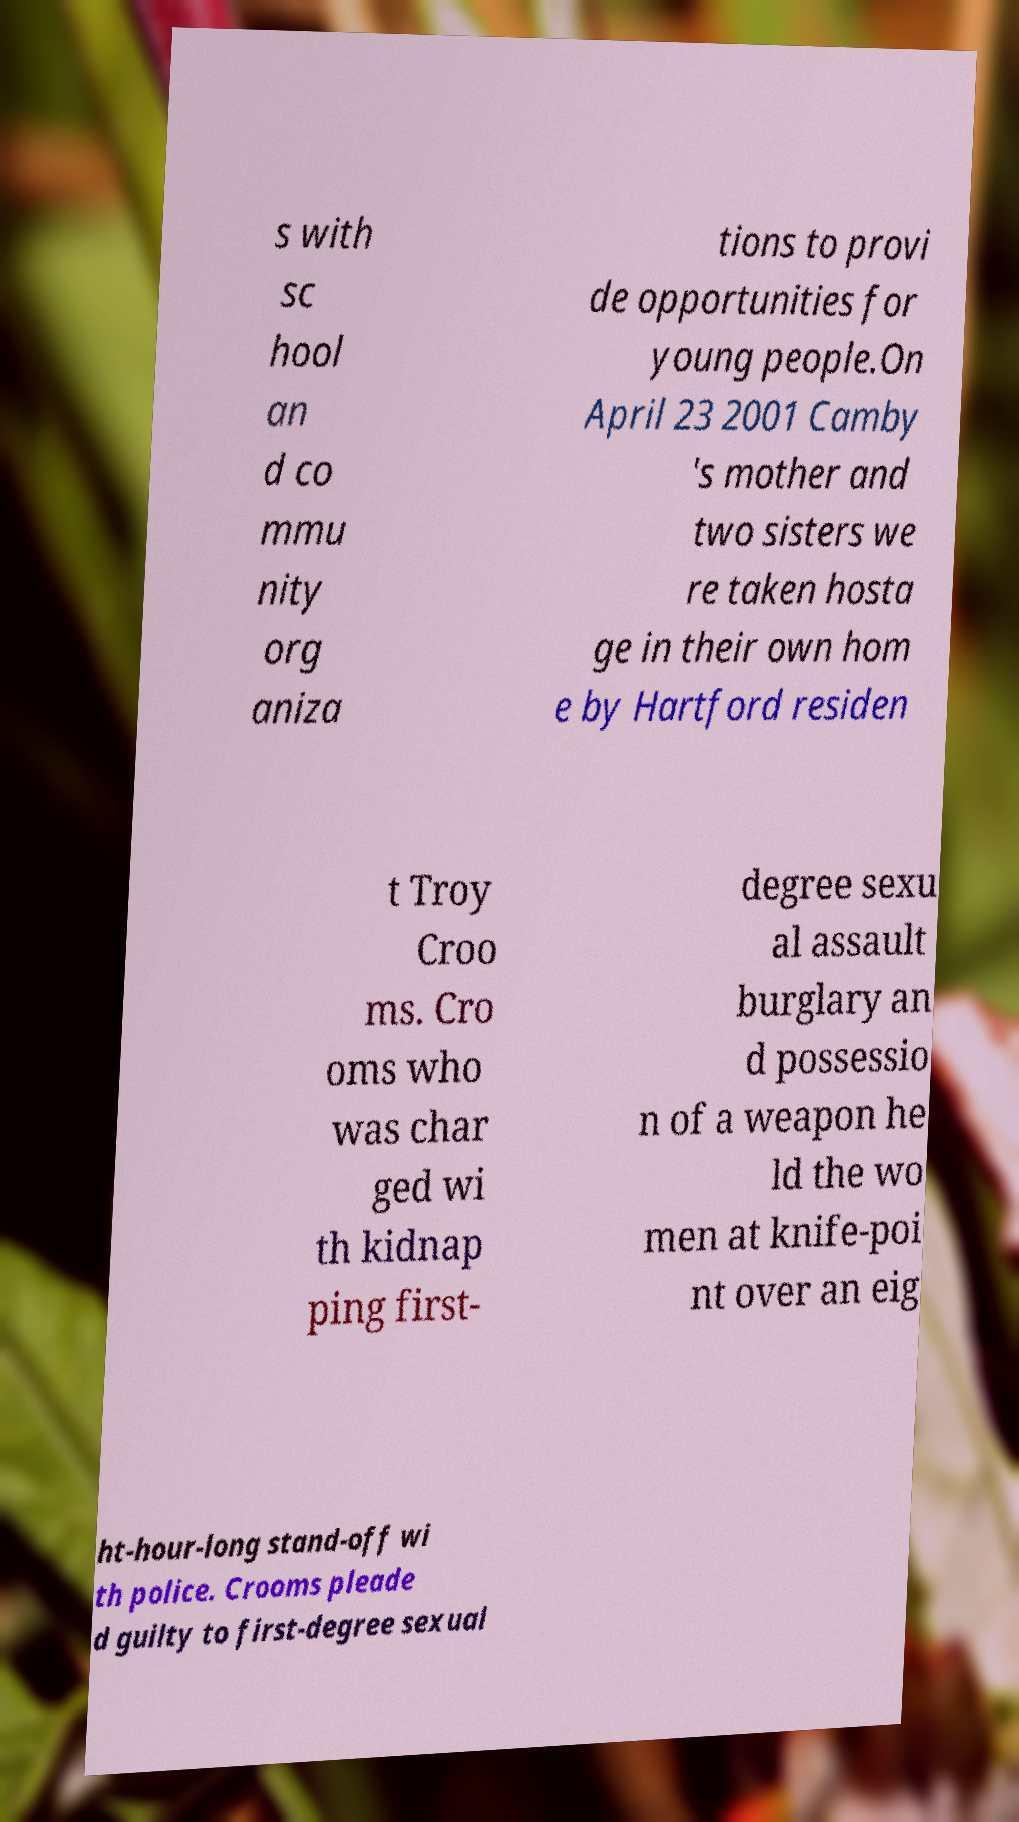I need the written content from this picture converted into text. Can you do that? s with sc hool an d co mmu nity org aniza tions to provi de opportunities for young people.On April 23 2001 Camby 's mother and two sisters we re taken hosta ge in their own hom e by Hartford residen t Troy Croo ms. Cro oms who was char ged wi th kidnap ping first- degree sexu al assault burglary an d possessio n of a weapon he ld the wo men at knife-poi nt over an eig ht-hour-long stand-off wi th police. Crooms pleade d guilty to first-degree sexual 